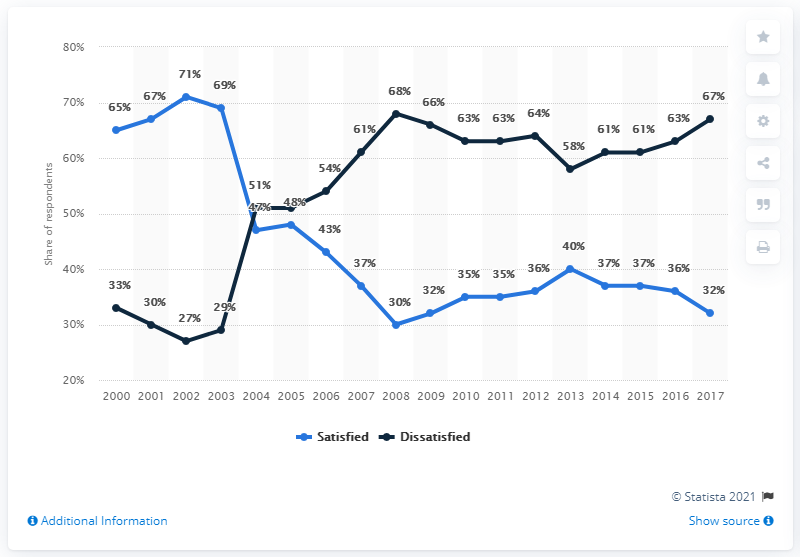Outline some significant characteristics in this image. For how many years has the satisfied rate been higher than the dissatisfied rate? The peak of the satisfied rate was reached in 2002. 